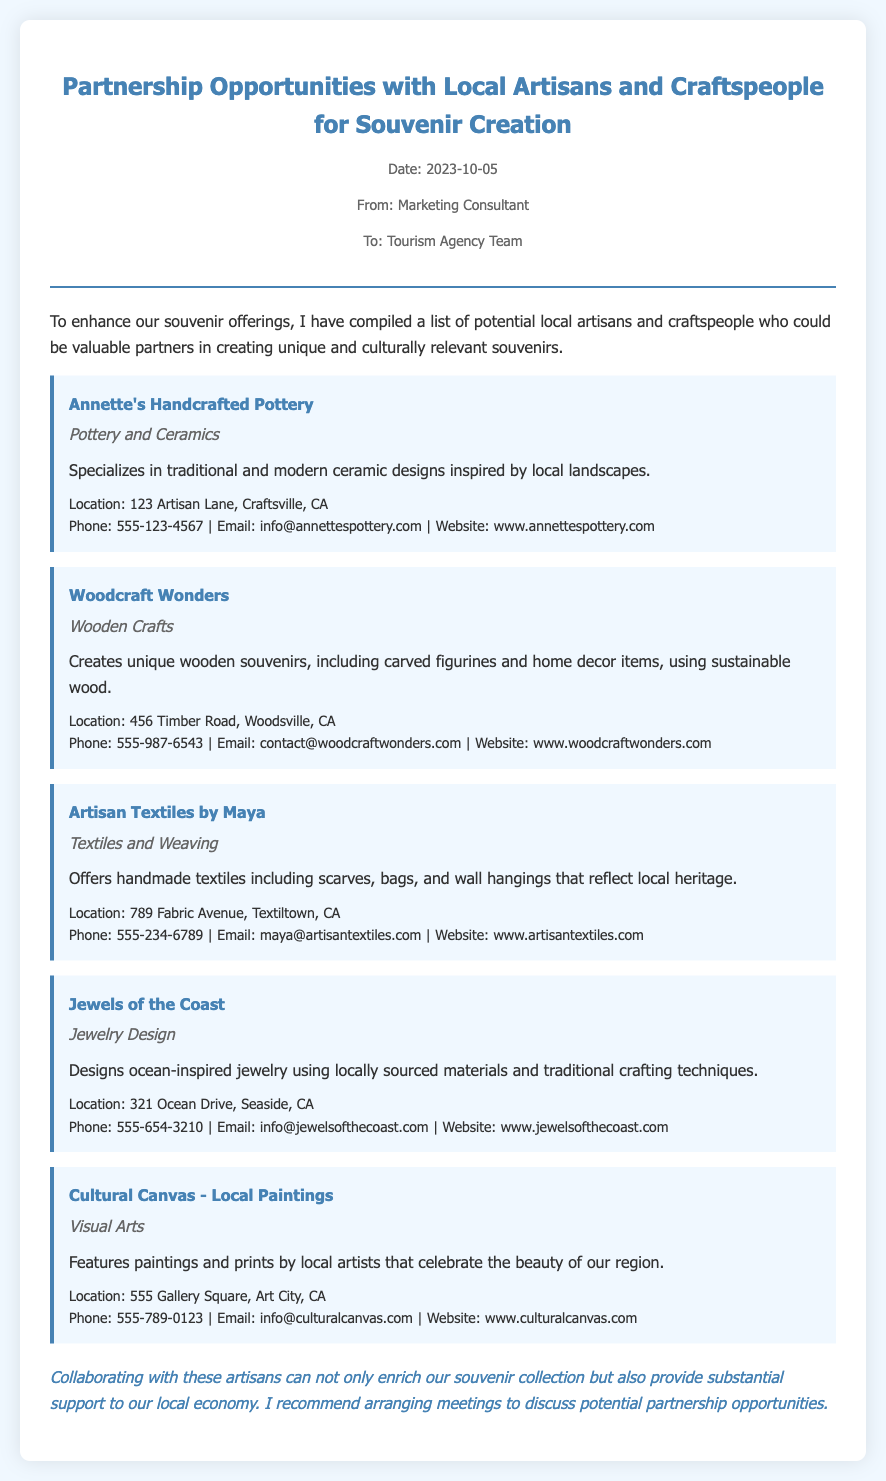What is the title of the memo? The title summarizes the purpose of the memo as it discusses partnership opportunities.
Answer: Partnership Opportunities with Local Artisans and Craftspeople for Souvenir Creation What date was the memo created? The date indicates when the memo was written and sent.
Answer: 2023-10-05 Who is the contact for Annette's Handcrafted Pottery? This person can provide more information or initiate a partnership discussion.
Answer: info@annettespottery.com Which artisan specializes in jewelry design? Identifying the artisan helps focus on specific products needed for souvenir creation.
Answer: Jewels of the Coast What type of crafts does Woodcraft Wonders create? This clarifies the category of products available for souvenir offerings.
Answer: Wooden Crafts Name one location where the potential artisans are located. This helps understand the local context of the artisans.
Answer: Craftsville Which artisan offers handmade textiles? This specifies the type of products offered by the artisan mentioned.
Answer: Artisan Textiles by Maya What common benefit do collaborations with artisans provide? This highlights the overarching goal of the partnerships discussed in the memo.
Answer: Support to our local economy How many artisans are listed in the memo? This provides a quick overview of the potential partnerships mentioned.
Answer: Five 